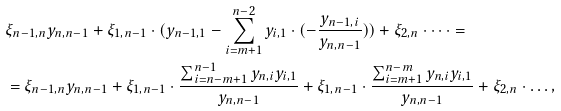Convert formula to latex. <formula><loc_0><loc_0><loc_500><loc_500>& \xi _ { n - 1 , n } y _ { n , n - 1 } + \xi _ { 1 , n - 1 } \cdot ( y _ { n - 1 , 1 } - \sum _ { i = m + 1 } ^ { n - 2 } y _ { i , 1 } \cdot ( - \frac { y _ { n - 1 , i } } { y _ { n , n - 1 } } ) ) + \xi _ { 2 , n } \cdot \dots = \\ & = \xi _ { n - 1 , n } y _ { n , n - 1 } + \xi _ { 1 , n - 1 } \cdot \frac { \sum _ { i = n - m + 1 } ^ { n - 1 } y _ { n , i } y _ { i , 1 } } { y _ { n , n - 1 } } + \xi _ { 1 , n - 1 } \cdot \frac { \sum _ { i = m + 1 } ^ { n - m } y _ { n , i } y _ { i , 1 } } { y _ { n , n - 1 } } + \xi _ { 2 , n } \cdot \dots , \\</formula> 